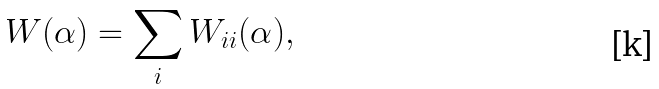<formula> <loc_0><loc_0><loc_500><loc_500>W ( \alpha ) = \sum _ { i } W _ { i i } ( \alpha ) ,</formula> 